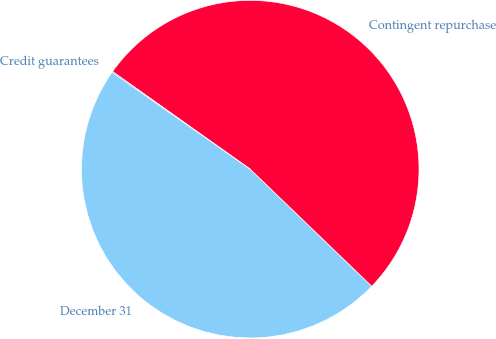Convert chart. <chart><loc_0><loc_0><loc_500><loc_500><pie_chart><fcel>December 31<fcel>Contingent repurchase<fcel>Credit guarantees<nl><fcel>47.52%<fcel>52.39%<fcel>0.09%<nl></chart> 